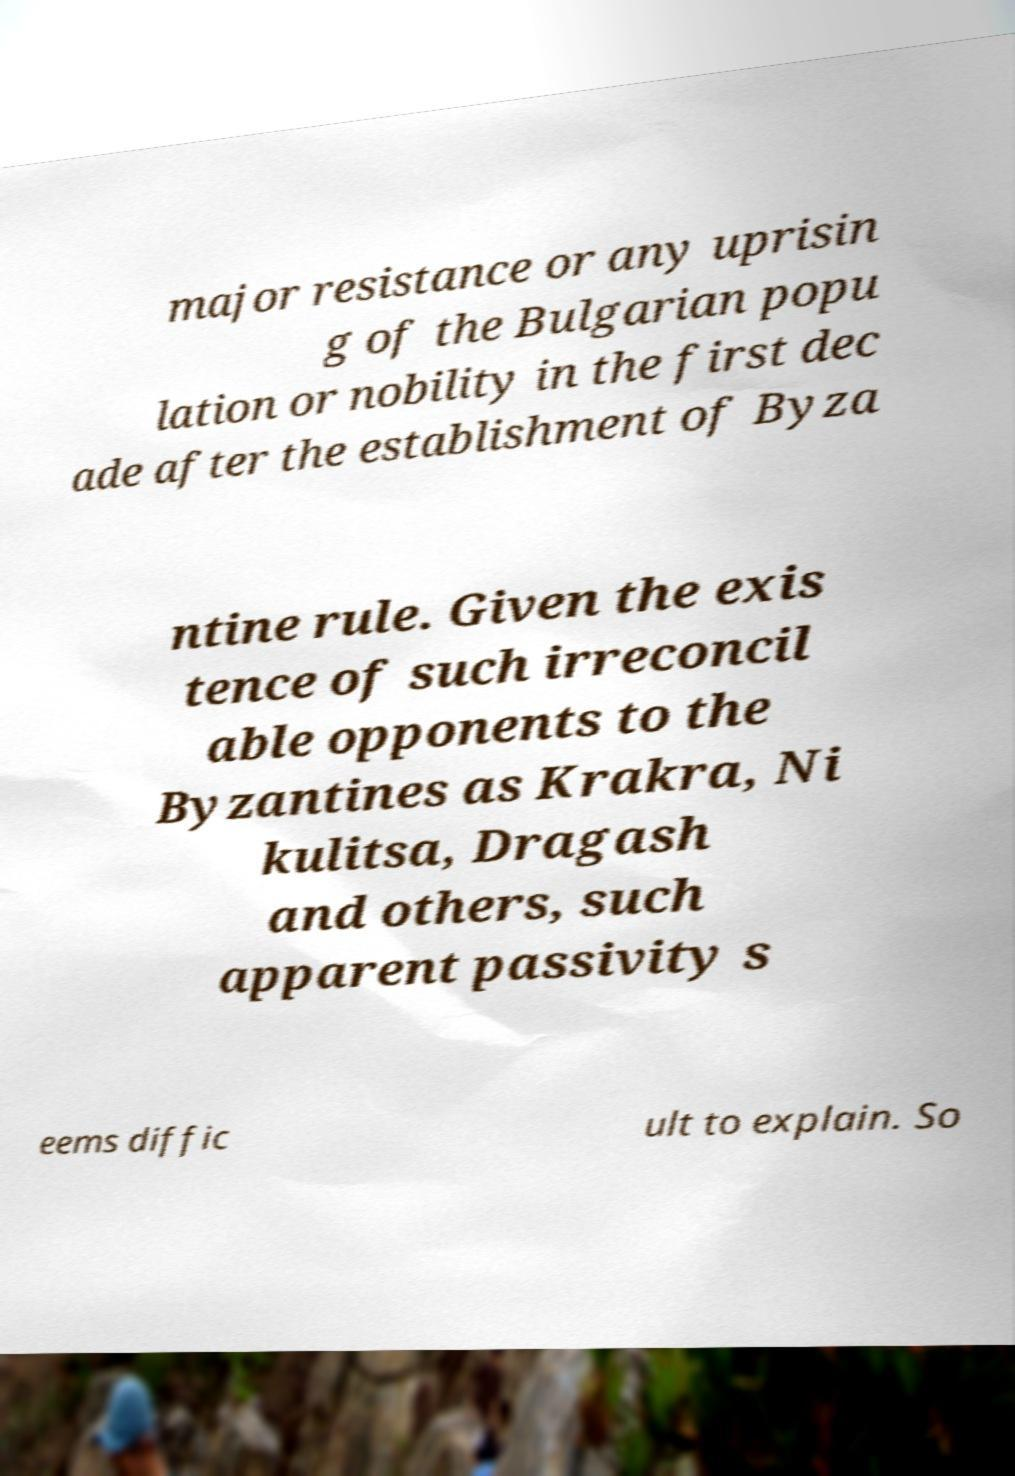Please identify and transcribe the text found in this image. major resistance or any uprisin g of the Bulgarian popu lation or nobility in the first dec ade after the establishment of Byza ntine rule. Given the exis tence of such irreconcil able opponents to the Byzantines as Krakra, Ni kulitsa, Dragash and others, such apparent passivity s eems diffic ult to explain. So 